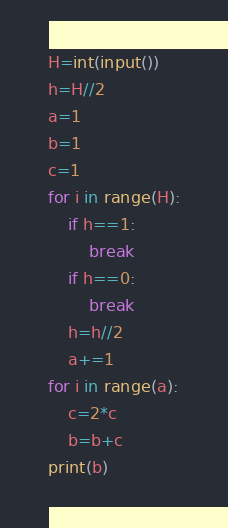Convert code to text. <code><loc_0><loc_0><loc_500><loc_500><_Python_>H=int(input())
h=H//2
a=1
b=1
c=1
for i in range(H):
    if h==1:
        break
    if h==0:
        break
    h=h//2
    a+=1
for i in range(a):
    c=2*c
    b=b+c
print(b)</code> 